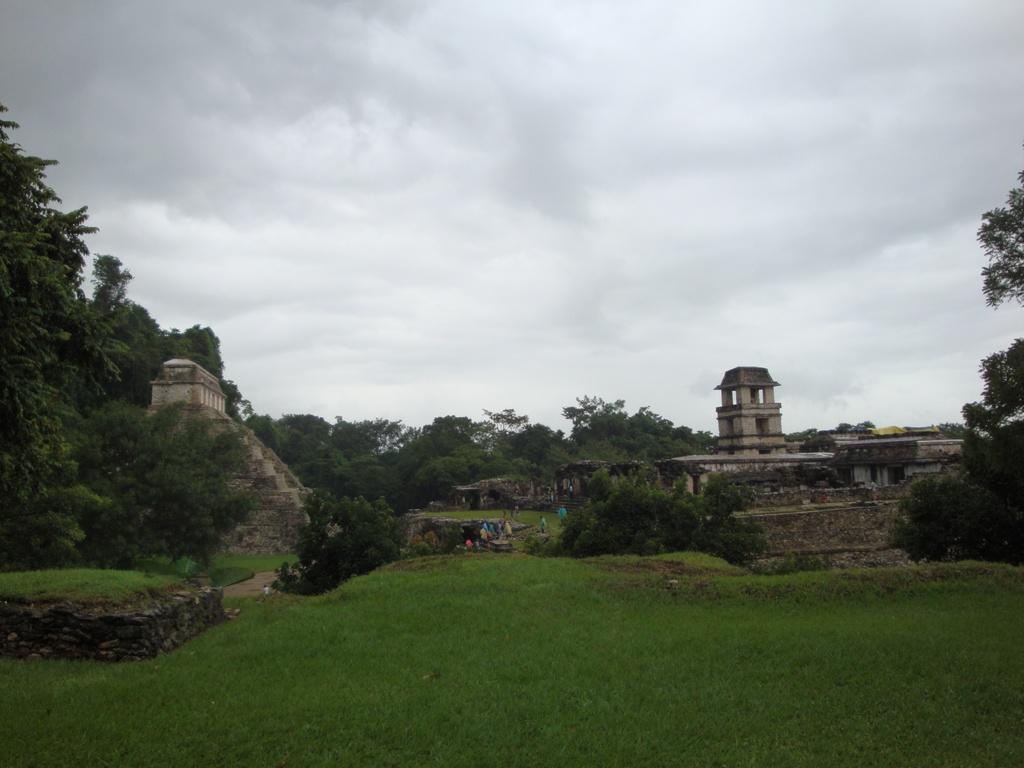Describe this image in one or two sentences. In this image there are people on the grassland having plants and walls. There are buildings. Background there are trees. Top of the image there is sky. 